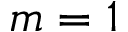<formula> <loc_0><loc_0><loc_500><loc_500>m = 1</formula> 